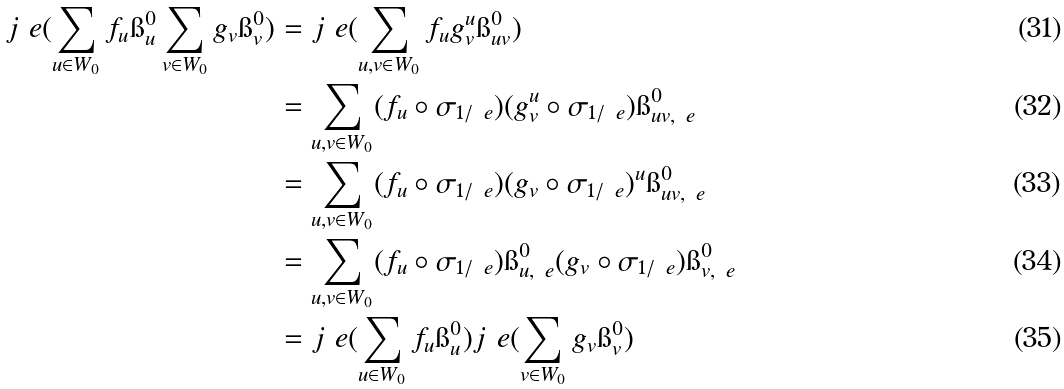<formula> <loc_0><loc_0><loc_500><loc_500>j _ { \ } e ( \sum _ { u \in W _ { 0 } } f _ { u } \i _ { u } ^ { 0 } \sum _ { v \in W _ { 0 } } g _ { v } \i _ { v } ^ { 0 } ) & = j _ { \ } e ( \sum _ { u , v \in W _ { 0 } } f _ { u } g ^ { u } _ { v } \i _ { u v } ^ { 0 } ) \\ & = \sum _ { u , v \in W _ { 0 } } ( f _ { u } \circ \sigma _ { 1 / \ e } ) ( g ^ { u } _ { v } \circ \sigma _ { 1 / \ e } ) \i _ { u v , \ e } ^ { 0 } \\ & = \sum _ { u , v \in W _ { 0 } } ( f _ { u } \circ \sigma _ { 1 / \ e } ) ( g _ { v } \circ \sigma _ { 1 / \ e } ) ^ { u } \i _ { u v , \ e } ^ { 0 } \\ & = \sum _ { u , v \in W _ { 0 } } ( f _ { u } \circ \sigma _ { 1 / \ e } ) \i _ { u , \ e } ^ { 0 } ( g _ { v } \circ \sigma _ { 1 / \ e } ) \i _ { v , \ e } ^ { 0 } \\ & = j _ { \ } e ( \sum _ { u \in W _ { 0 } } f _ { u } \i _ { u } ^ { 0 } ) j _ { \ } e ( \sum _ { v \in W _ { 0 } } g _ { v } \i _ { v } ^ { 0 } )</formula> 